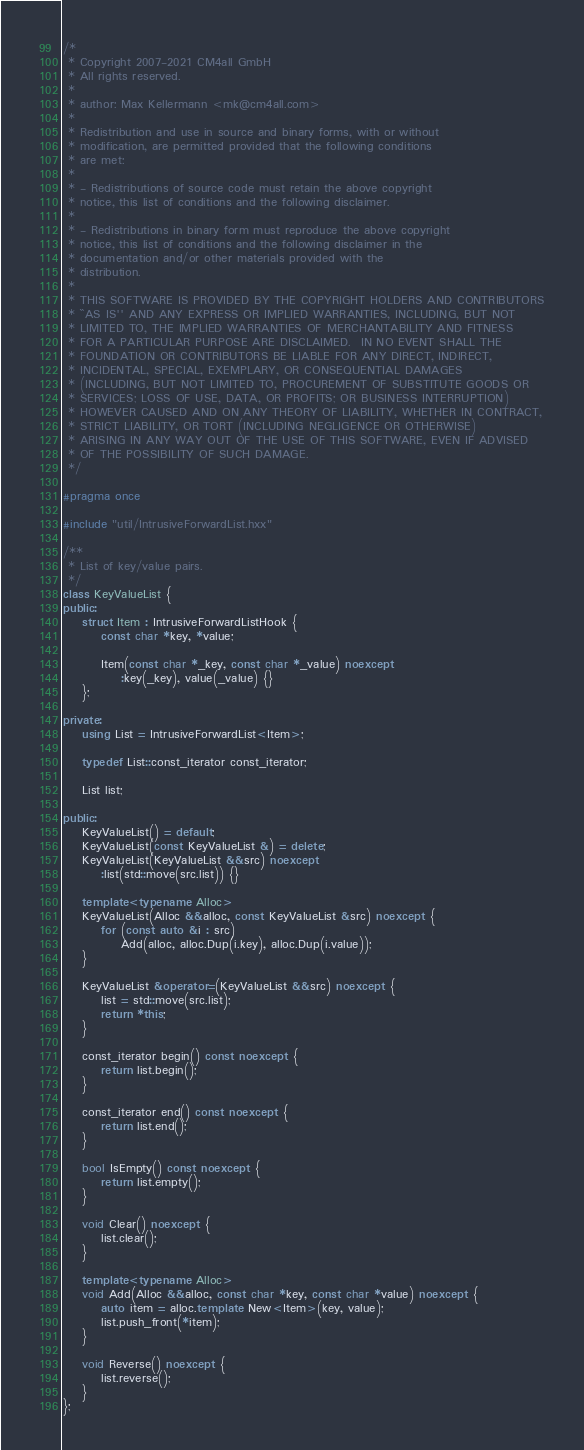<code> <loc_0><loc_0><loc_500><loc_500><_C++_>/*
 * Copyright 2007-2021 CM4all GmbH
 * All rights reserved.
 *
 * author: Max Kellermann <mk@cm4all.com>
 *
 * Redistribution and use in source and binary forms, with or without
 * modification, are permitted provided that the following conditions
 * are met:
 *
 * - Redistributions of source code must retain the above copyright
 * notice, this list of conditions and the following disclaimer.
 *
 * - Redistributions in binary form must reproduce the above copyright
 * notice, this list of conditions and the following disclaimer in the
 * documentation and/or other materials provided with the
 * distribution.
 *
 * THIS SOFTWARE IS PROVIDED BY THE COPYRIGHT HOLDERS AND CONTRIBUTORS
 * ``AS IS'' AND ANY EXPRESS OR IMPLIED WARRANTIES, INCLUDING, BUT NOT
 * LIMITED TO, THE IMPLIED WARRANTIES OF MERCHANTABILITY AND FITNESS
 * FOR A PARTICULAR PURPOSE ARE DISCLAIMED.  IN NO EVENT SHALL THE
 * FOUNDATION OR CONTRIBUTORS BE LIABLE FOR ANY DIRECT, INDIRECT,
 * INCIDENTAL, SPECIAL, EXEMPLARY, OR CONSEQUENTIAL DAMAGES
 * (INCLUDING, BUT NOT LIMITED TO, PROCUREMENT OF SUBSTITUTE GOODS OR
 * SERVICES; LOSS OF USE, DATA, OR PROFITS; OR BUSINESS INTERRUPTION)
 * HOWEVER CAUSED AND ON ANY THEORY OF LIABILITY, WHETHER IN CONTRACT,
 * STRICT LIABILITY, OR TORT (INCLUDING NEGLIGENCE OR OTHERWISE)
 * ARISING IN ANY WAY OUT OF THE USE OF THIS SOFTWARE, EVEN IF ADVISED
 * OF THE POSSIBILITY OF SUCH DAMAGE.
 */

#pragma once

#include "util/IntrusiveForwardList.hxx"

/**
 * List of key/value pairs.
 */
class KeyValueList {
public:
	struct Item : IntrusiveForwardListHook {
		const char *key, *value;

		Item(const char *_key, const char *_value) noexcept
			:key(_key), value(_value) {}
	};

private:
	using List = IntrusiveForwardList<Item>;

	typedef List::const_iterator const_iterator;

	List list;

public:
	KeyValueList() = default;
	KeyValueList(const KeyValueList &) = delete;
	KeyValueList(KeyValueList &&src) noexcept
		:list(std::move(src.list)) {}

	template<typename Alloc>
	KeyValueList(Alloc &&alloc, const KeyValueList &src) noexcept {
		for (const auto &i : src)
			Add(alloc, alloc.Dup(i.key), alloc.Dup(i.value));
	}

	KeyValueList &operator=(KeyValueList &&src) noexcept {
		list = std::move(src.list);
		return *this;
	}

	const_iterator begin() const noexcept {
		return list.begin();
	}

	const_iterator end() const noexcept {
		return list.end();
	}

	bool IsEmpty() const noexcept {
		return list.empty();
	}

	void Clear() noexcept {
		list.clear();
	}

	template<typename Alloc>
	void Add(Alloc &&alloc, const char *key, const char *value) noexcept {
		auto item = alloc.template New<Item>(key, value);
		list.push_front(*item);
	}

	void Reverse() noexcept {
		list.reverse();
	}
};
</code> 